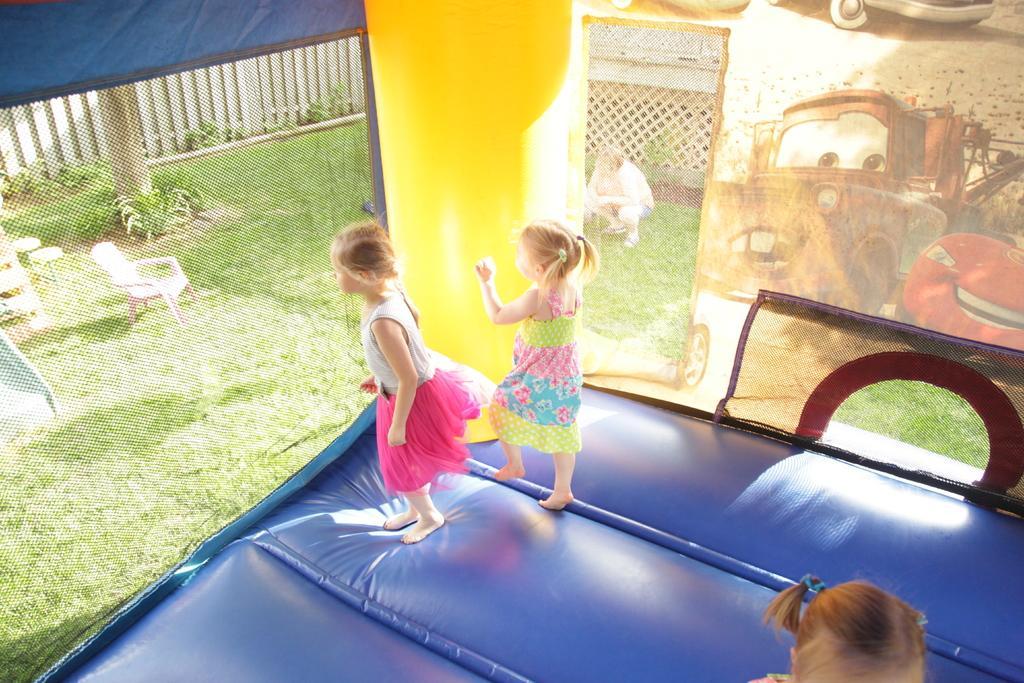How would you summarize this image in a sentence or two? Here I can see three girls are jumping on a inflatable castle. On the left side, I can see the grass and there are few empty chairs. On the right side, I can see a banner and a person is sitting on the ground. 